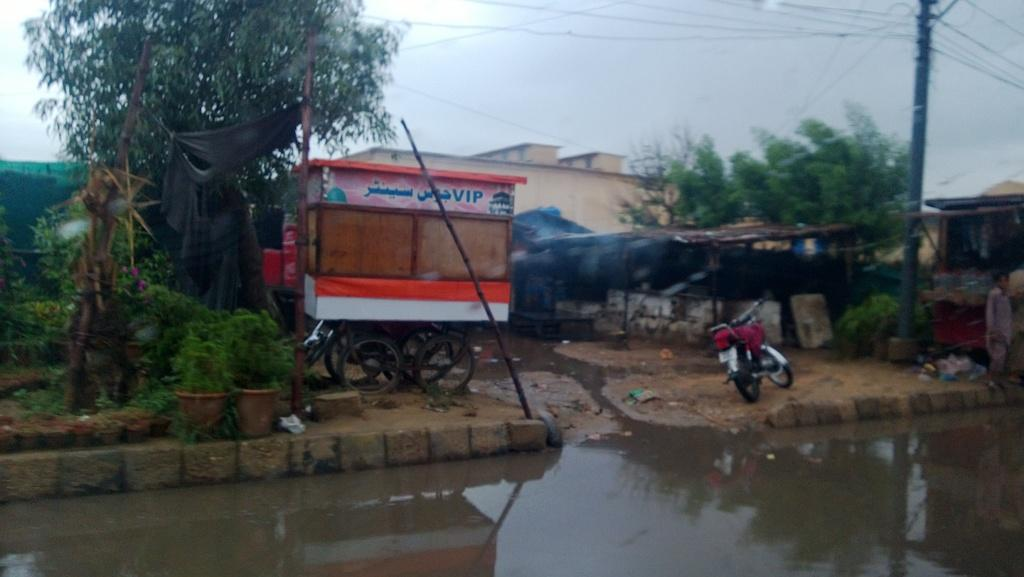What type of natural elements can be seen in the image? There are trees in the image. What type of man-made structures are present in the image? There are buildings in the image. What type of transportation is visible in the image? There are vehicles in the image. What type of decorative items can be seen in the image? There are flowerpots in the image. What type of sports equipment is present in the image? There is a net in the image. What type of natural feature is visible in the image? There is water visible in the image. What type of utility pole is present in the image? There is a current pole in the image. What type of electrical infrastructure is visible in the image? There are wires in the image. What is the color of the sky in the image? The sky is in white and blue color. Where is the kettle located in the image? There is no kettle present in the image. What type of pin is holding the trees together in the image? There is no pin holding the trees together in the image; they are separate trees. 